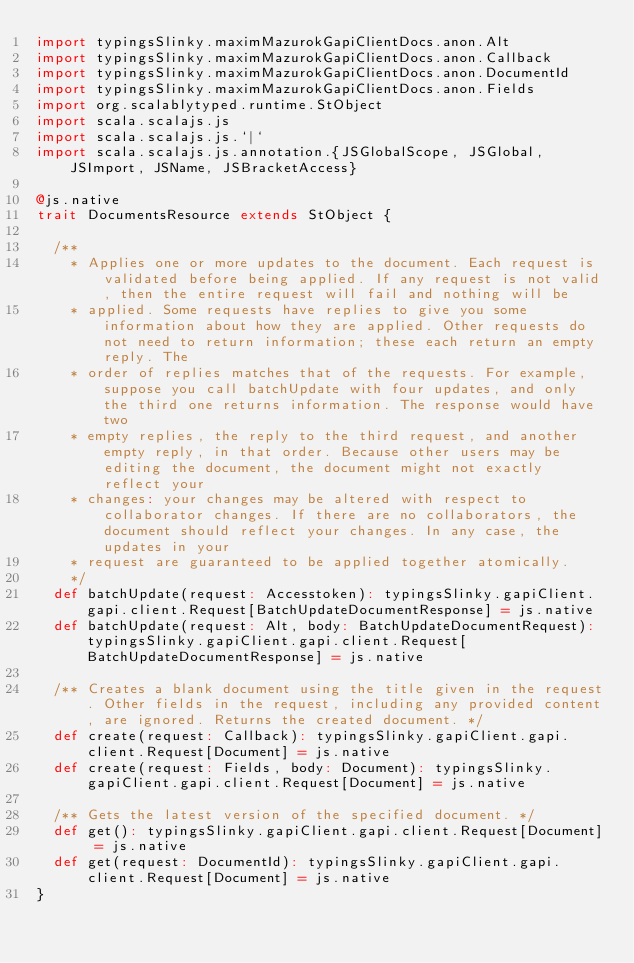<code> <loc_0><loc_0><loc_500><loc_500><_Scala_>import typingsSlinky.maximMazurokGapiClientDocs.anon.Alt
import typingsSlinky.maximMazurokGapiClientDocs.anon.Callback
import typingsSlinky.maximMazurokGapiClientDocs.anon.DocumentId
import typingsSlinky.maximMazurokGapiClientDocs.anon.Fields
import org.scalablytyped.runtime.StObject
import scala.scalajs.js
import scala.scalajs.js.`|`
import scala.scalajs.js.annotation.{JSGlobalScope, JSGlobal, JSImport, JSName, JSBracketAccess}

@js.native
trait DocumentsResource extends StObject {
  
  /**
    * Applies one or more updates to the document. Each request is validated before being applied. If any request is not valid, then the entire request will fail and nothing will be
    * applied. Some requests have replies to give you some information about how they are applied. Other requests do not need to return information; these each return an empty reply. The
    * order of replies matches that of the requests. For example, suppose you call batchUpdate with four updates, and only the third one returns information. The response would have two
    * empty replies, the reply to the third request, and another empty reply, in that order. Because other users may be editing the document, the document might not exactly reflect your
    * changes: your changes may be altered with respect to collaborator changes. If there are no collaborators, the document should reflect your changes. In any case, the updates in your
    * request are guaranteed to be applied together atomically.
    */
  def batchUpdate(request: Accesstoken): typingsSlinky.gapiClient.gapi.client.Request[BatchUpdateDocumentResponse] = js.native
  def batchUpdate(request: Alt, body: BatchUpdateDocumentRequest): typingsSlinky.gapiClient.gapi.client.Request[BatchUpdateDocumentResponse] = js.native
  
  /** Creates a blank document using the title given in the request. Other fields in the request, including any provided content, are ignored. Returns the created document. */
  def create(request: Callback): typingsSlinky.gapiClient.gapi.client.Request[Document] = js.native
  def create(request: Fields, body: Document): typingsSlinky.gapiClient.gapi.client.Request[Document] = js.native
  
  /** Gets the latest version of the specified document. */
  def get(): typingsSlinky.gapiClient.gapi.client.Request[Document] = js.native
  def get(request: DocumentId): typingsSlinky.gapiClient.gapi.client.Request[Document] = js.native
}
</code> 